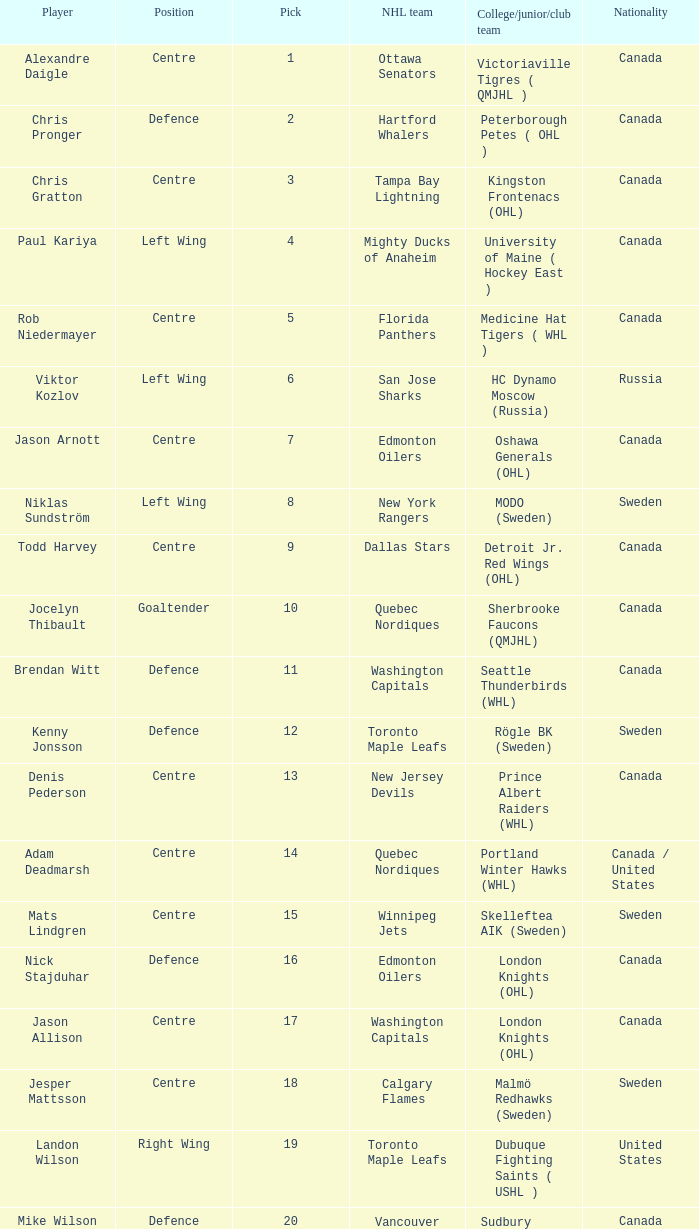How many NHL teams is Denis Pederson a draft pick for? 1.0. 